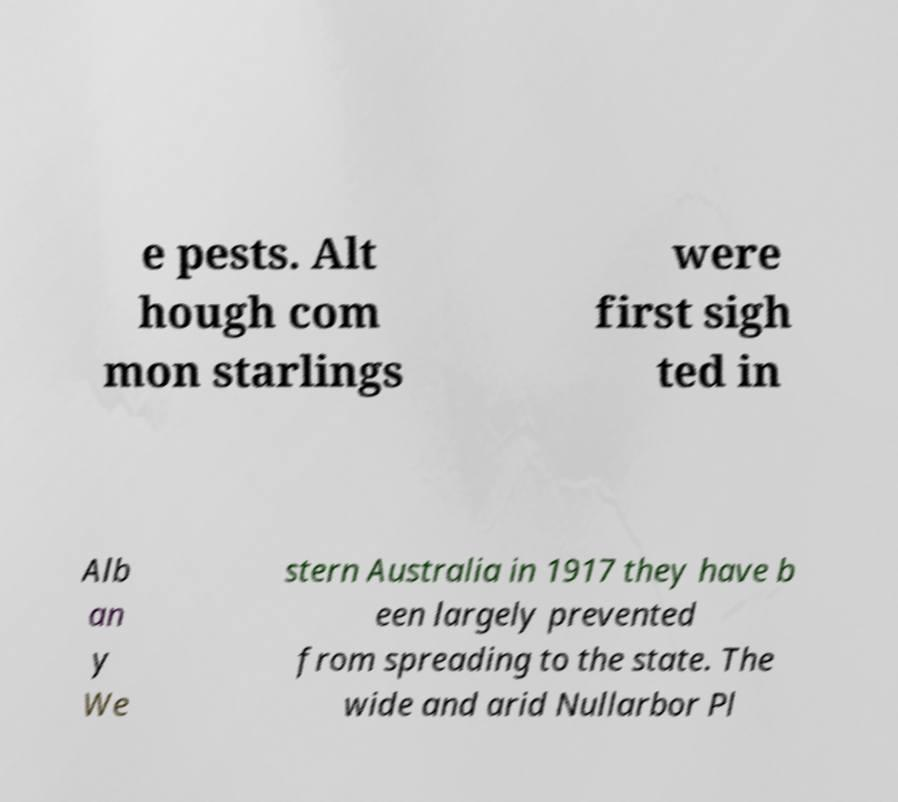Could you assist in decoding the text presented in this image and type it out clearly? e pests. Alt hough com mon starlings were first sigh ted in Alb an y We stern Australia in 1917 they have b een largely prevented from spreading to the state. The wide and arid Nullarbor Pl 